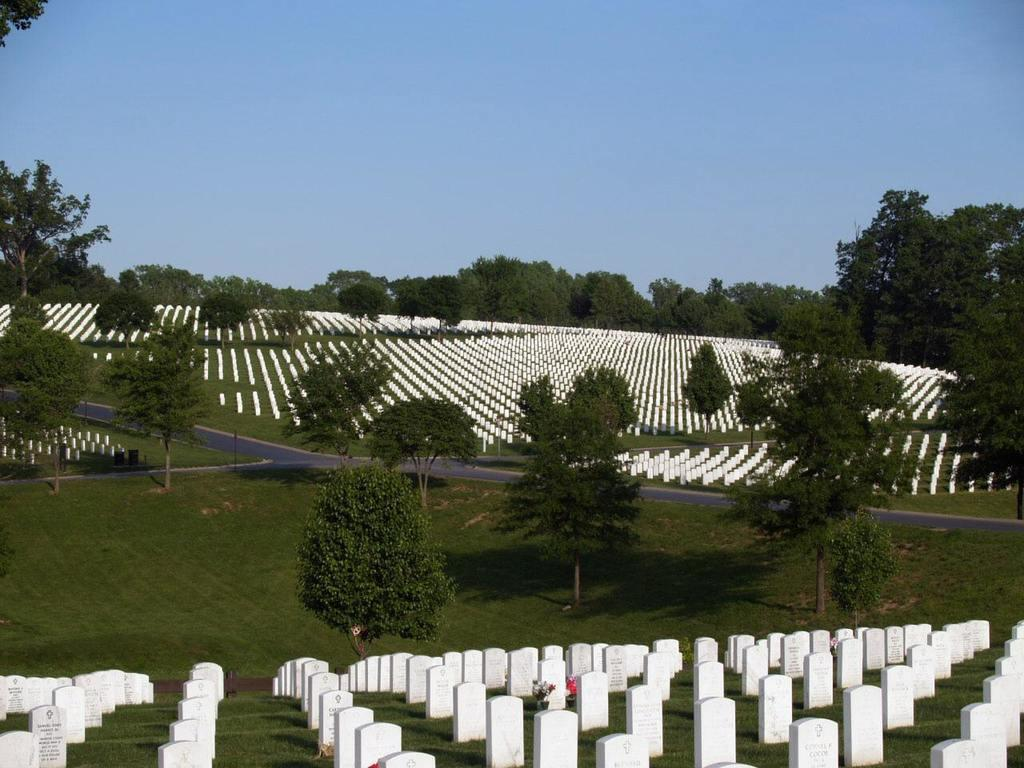What type of location is depicted in the image? There is a graveyard in the image. What is covering the ground in the graveyard? The ground in the graveyard is covered with grass. What can be seen in the background of the image? There are trees visible in the background of the image. How would you describe the sky in the image? The sky is clear in the image. What type of haircut does the tree in the image have? There are no haircuts mentioned or depicted in the image, as it features a graveyard with trees in the background. 